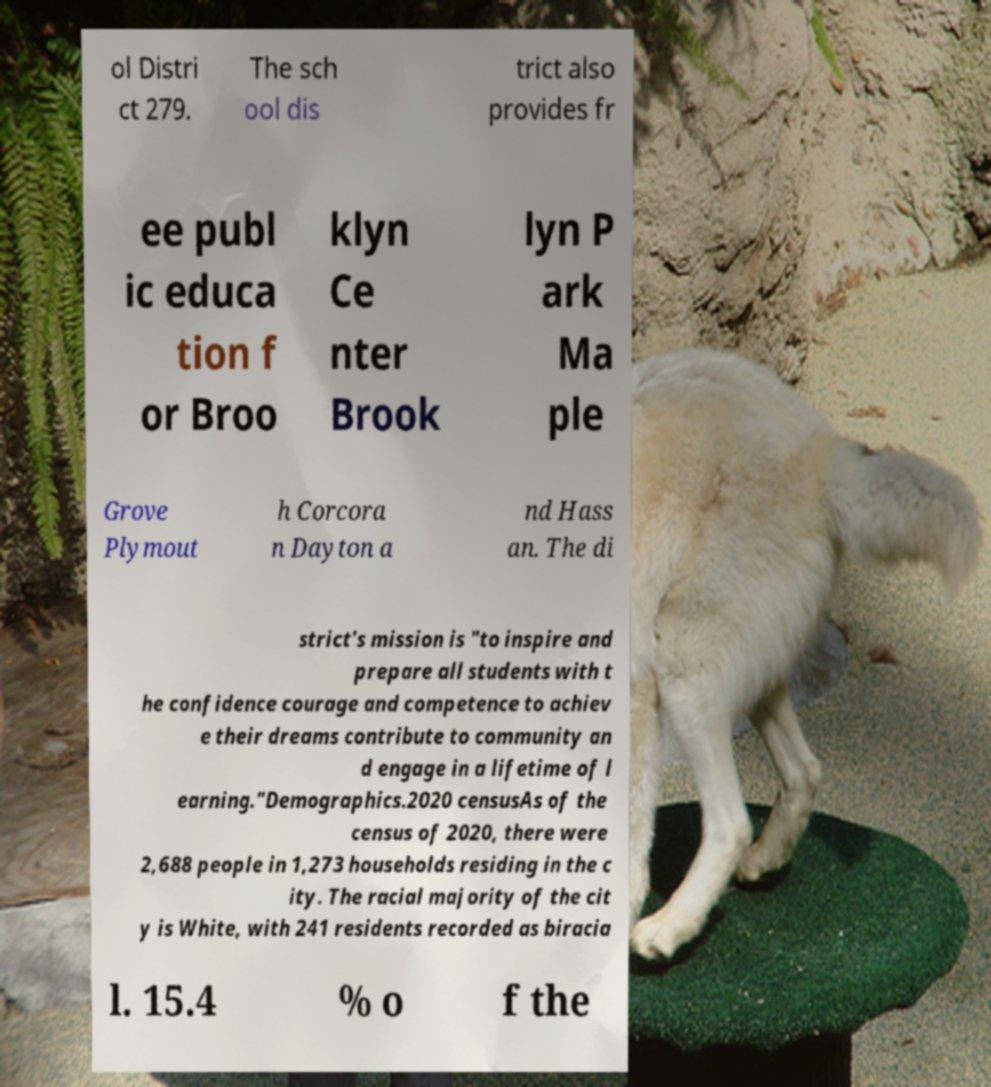Please read and relay the text visible in this image. What does it say? ol Distri ct 279. The sch ool dis trict also provides fr ee publ ic educa tion f or Broo klyn Ce nter Brook lyn P ark Ma ple Grove Plymout h Corcora n Dayton a nd Hass an. The di strict's mission is "to inspire and prepare all students with t he confidence courage and competence to achiev e their dreams contribute to community an d engage in a lifetime of l earning."Demographics.2020 censusAs of the census of 2020, there were 2,688 people in 1,273 households residing in the c ity. The racial majority of the cit y is White, with 241 residents recorded as biracia l. 15.4 % o f the 